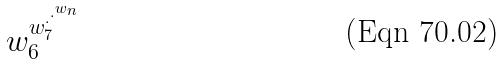Convert formula to latex. <formula><loc_0><loc_0><loc_500><loc_500>w _ { 6 } ^ { w _ { 7 } ^ { \cdot ^ { \cdot ^ { w _ { n } } } } }</formula> 